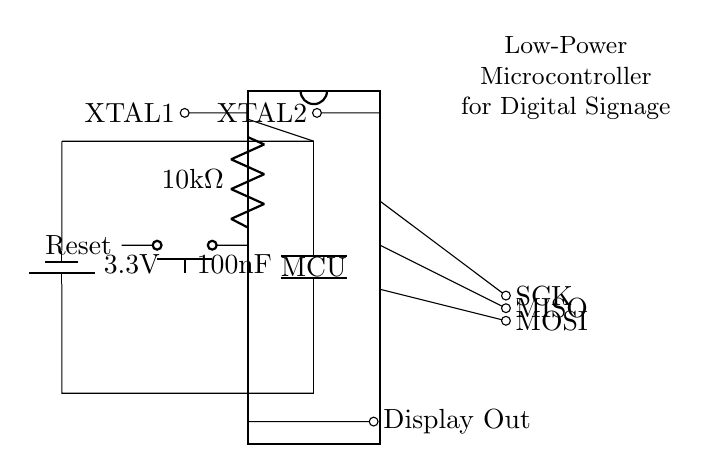What is the type of the main component in this circuit? The main component is a low-power microcontroller, identified as "MCU" in the diagram.
Answer: microcontroller What is the power supply voltage in this circuit? The circuit is powered by a battery providing a voltage of 3.3 volts, as indicated near the battery symbol.
Answer: 3.3 volts How many pins does the microcontroller have? The microcontroller has 16 pins, labeled on the DIP chip representation in the diagram.
Answer: 16 pins What is the value of the resistor connected to the reset circuit? The resistor connected to the reset circuit is labeled as 10 kiloohms in the diagram.
Answer: 10 kiloohms Which component is used for frequency stabilization? The components used for frequency stabilization are the crystal oscillator pins labeled XTAL1 and XTAL2.
Answer: crystal oscillator What is the purpose of the capacitor in this circuit? The capacitor is used for power decoupling, ensuring stability in voltage supply, indicated with the label of 100 nanofarads.
Answer: power decoupling Which signals are used for programming the microcontroller? The signals used for programming the microcontroller include MOSI, MISO, and SCK, as indicated by their labels on respective output lines.
Answer: MOSI, MISO, SCK 